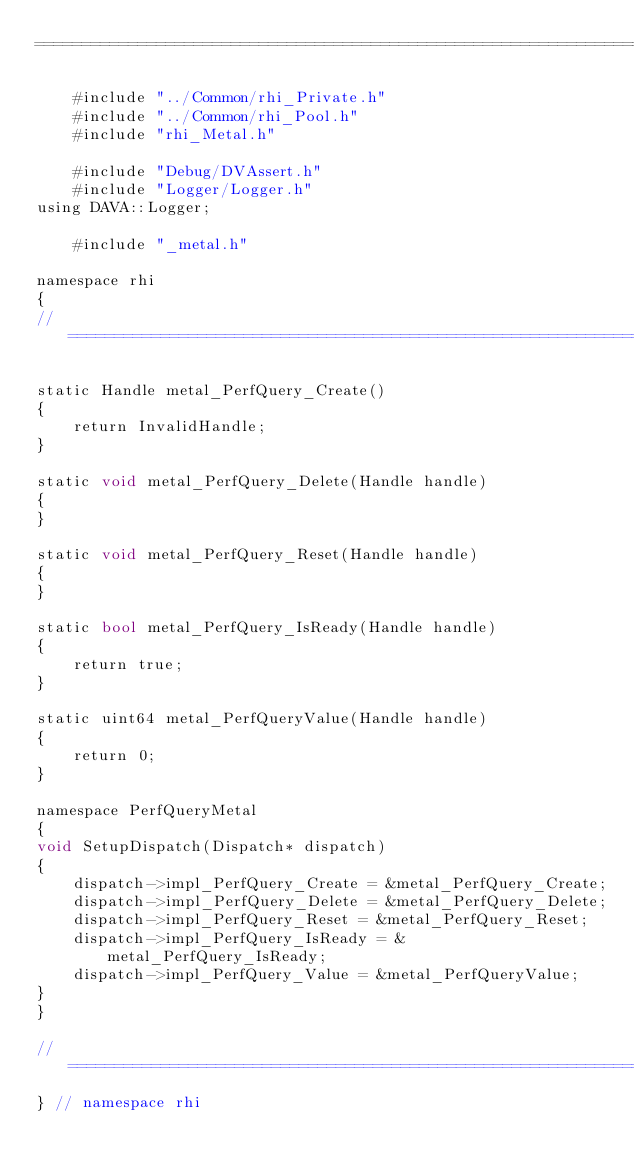Convert code to text. <code><loc_0><loc_0><loc_500><loc_500><_ObjectiveC_>=====================================================================================*/

    #include "../Common/rhi_Private.h"
    #include "../Common/rhi_Pool.h"
    #include "rhi_Metal.h"

    #include "Debug/DVAssert.h"
    #include "Logger/Logger.h"
using DAVA::Logger;

    #include "_metal.h"

namespace rhi
{
//==============================================================================

static Handle metal_PerfQuery_Create()
{
    return InvalidHandle;
}

static void metal_PerfQuery_Delete(Handle handle)
{
}

static void metal_PerfQuery_Reset(Handle handle)
{
}

static bool metal_PerfQuery_IsReady(Handle handle)
{
    return true;
}

static uint64 metal_PerfQueryValue(Handle handle)
{
    return 0;
}

namespace PerfQueryMetal
{
void SetupDispatch(Dispatch* dispatch)
{
    dispatch->impl_PerfQuery_Create = &metal_PerfQuery_Create;
    dispatch->impl_PerfQuery_Delete = &metal_PerfQuery_Delete;
    dispatch->impl_PerfQuery_Reset = &metal_PerfQuery_Reset;
    dispatch->impl_PerfQuery_IsReady = &metal_PerfQuery_IsReady;
    dispatch->impl_PerfQuery_Value = &metal_PerfQueryValue;
}
}

//==============================================================================
} // namespace rhi
</code> 